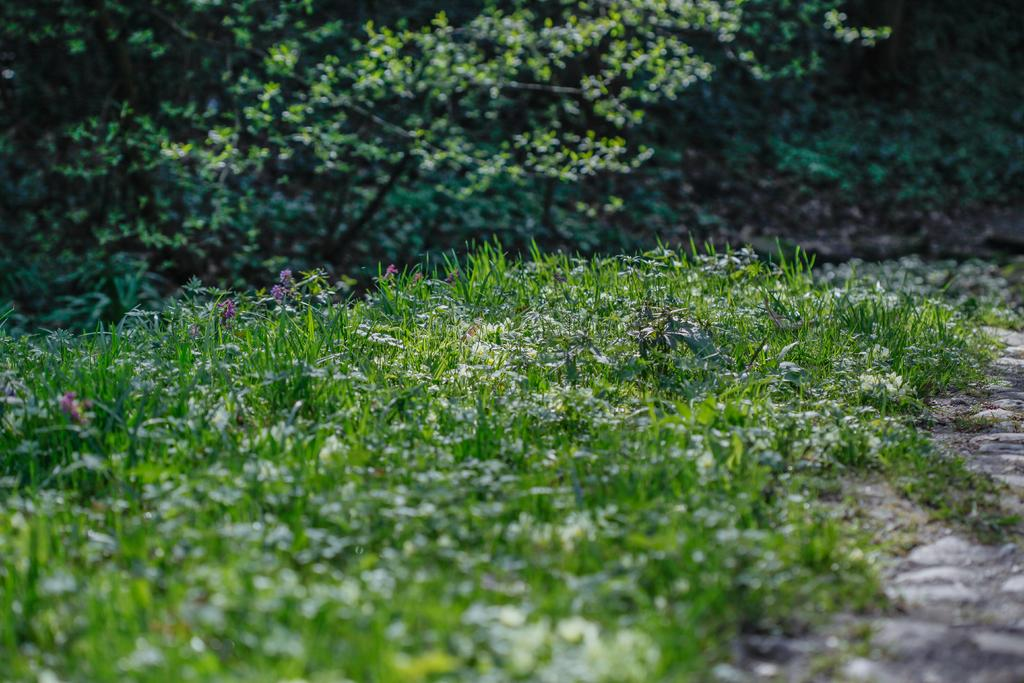What type of vegetation is present in the image? There is grass and plants with flowers on the ground in the image. Are there any plants in the background of the image? Yes, there are plants in the background of the image. How many fans can be seen in the image? There are no fans present in the image; it features vegetation and plants. What type of horses are depicted in the image? There are no horses present in the image. 